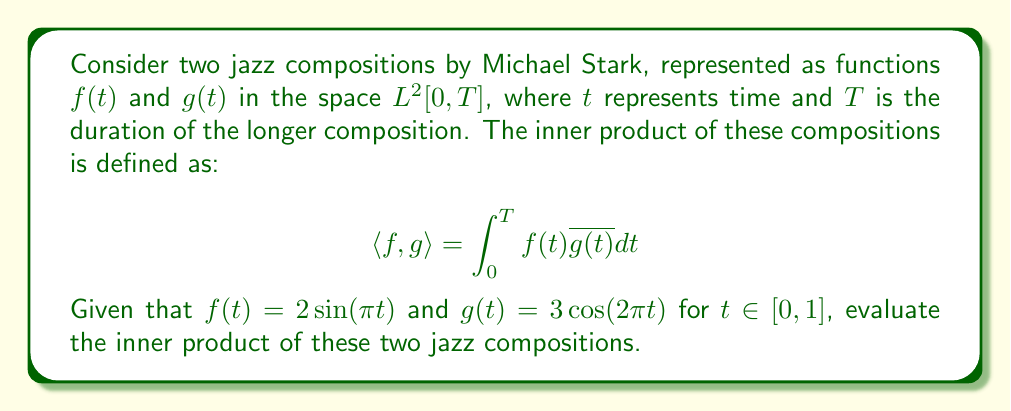What is the answer to this math problem? To evaluate the inner product of the two jazz compositions, we need to follow these steps:

1) We are given that $f(t) = 2\sin(\pi t)$ and $g(t) = 3\cos(2\pi t)$ for $t \in [0,1]$. This means $T = 1$.

2) We need to calculate:

   $$ \langle f,g \rangle = \int_0^1 f(t)\overline{g(t)} dt $$

3) Since $g(t)$ is real-valued, $\overline{g(t)} = g(t)$. So we have:

   $$ \langle f,g \rangle = \int_0^1 2\sin(\pi t) \cdot 3\cos(2\pi t) dt $$

4) Simplify the integrand:

   $$ \langle f,g \rangle = 6\int_0^1 \sin(\pi t)\cos(2\pi t) dt $$

5) We can solve this using the trigonometric product-to-sum formula:

   $$ \sin A \cos B = \frac{1}{2}[\sin(A-B) + \sin(A+B)] $$

   Here, $A = \pi t$ and $B = 2\pi t$

6) Applying the formula:

   $$ \langle f,g \rangle = 6\int_0^1 \frac{1}{2}[\sin(\pi t - 2\pi t) + \sin(\pi t + 2\pi t)] dt $$
   $$ = 6\int_0^1 \frac{1}{2}[\sin(-\pi t) + \sin(3\pi t)] dt $$
   $$ = 3\int_0^1 [-\sin(\pi t) + \sin(3\pi t)] dt $$

7) Now we can integrate:

   $$ = 3\left[\frac{\cos(\pi t)}{\pi} - \frac{\cos(3\pi t)}{3\pi}\right]_0^1 $$

8) Evaluate the definite integral:

   $$ = 3\left[(\frac{\cos(\pi)}{\pi} - \frac{\cos(3\pi)}{3\pi}) - (\frac{\cos(0)}{\pi} - \frac{\cos(0)}{3\pi})\right] $$
   $$ = 3\left[(\frac{-1}{\pi} - \frac{-1}{3\pi}) - (\frac{1}{\pi} - \frac{1}{3\pi})\right] $$
   $$ = 3\left[-\frac{2}{\pi} + \frac{2}{3\pi}\right] $$
   $$ = 3\left[-\frac{4}{3\pi}\right] $$
   $$ = -\frac{4}{\pi} $$

Therefore, the inner product of the two jazz compositions is $-\frac{4}{\pi}$.
Answer: $-\frac{4}{\pi}$ 